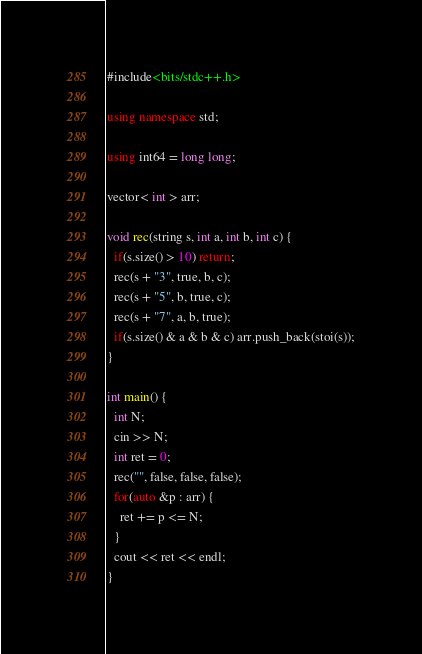<code> <loc_0><loc_0><loc_500><loc_500><_C++_>#include<bits/stdc++.h>

using namespace std;

using int64 = long long;

vector< int > arr;

void rec(string s, int a, int b, int c) {
  if(s.size() > 10) return;
  rec(s + "3", true, b, c);
  rec(s + "5", b, true, c);
  rec(s + "7", a, b, true);
  if(s.size() & a & b & c) arr.push_back(stoi(s));
}

int main() {
  int N;
  cin >> N;
  int ret = 0;
  rec("", false, false, false);
  for(auto &p : arr) {
    ret += p <= N;
  }
  cout << ret << endl;
}</code> 